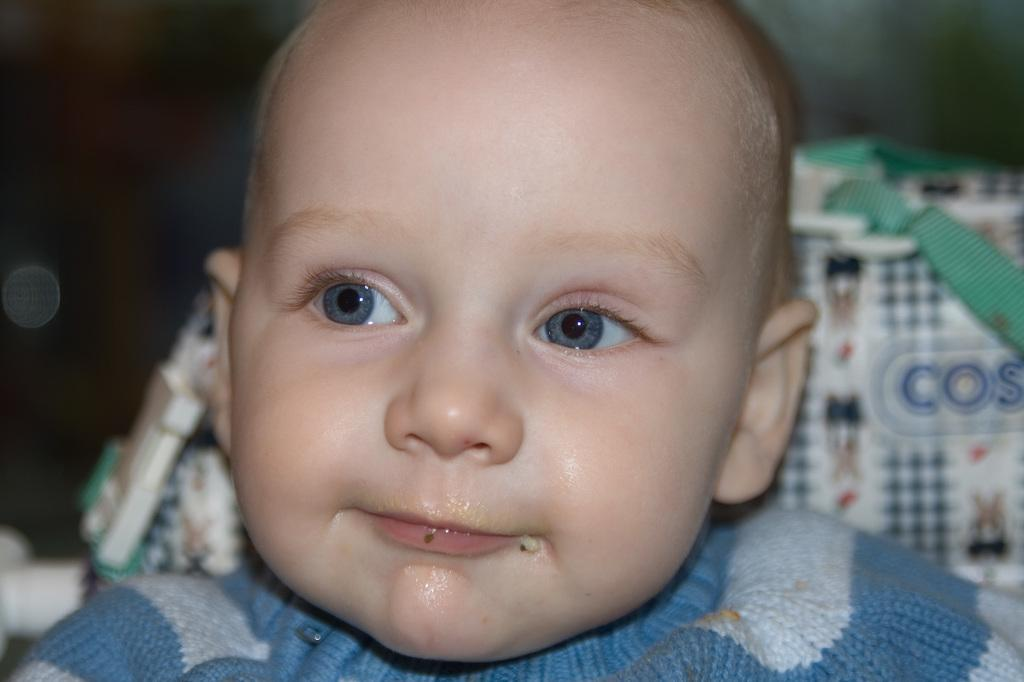What is the main subject of the image? There is a baby boy in the image. What is the baby boy doing in the image? The baby boy is smiling. What is the baby boy wearing in the image? The baby boy is wearing a shirt. Can you describe any other objects in the image? There appears to be a bag in the image. How would you describe the background of the image? The background of the image is blurry. Does the baby boy have wings in the image? No, the baby boy does not have wings in the image. What type of test is the baby boy taking in the image? There is no test present in the image; the baby boy is simply smiling. 